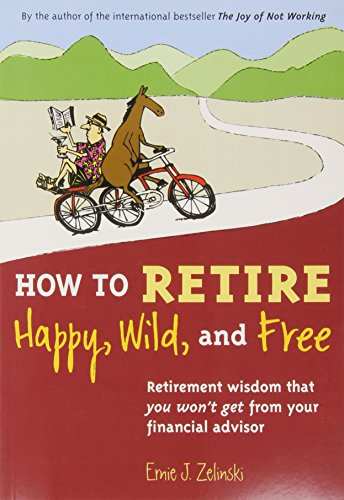Who wrote this book? The book 'How to Retire Happy, Wild, and Free' was written by Ernie J. Zelinski. 